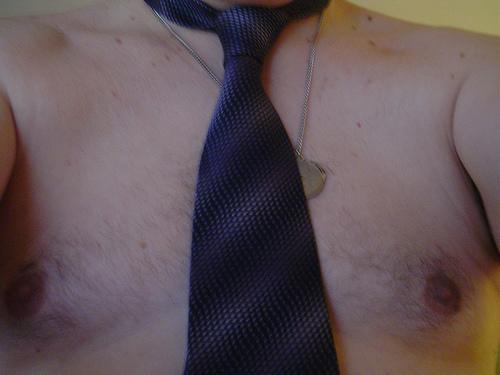What is the name of the clothing?
Quick response, please. Tie. What are the red circles?
Concise answer only. Nipples. Is this person wearing a necklace?
Concise answer only. Yes. Are these clothes appropriate for work?
Quick response, please. No. Is this man sleeping?
Concise answer only. No. Is the human looking figure overweight?
Concise answer only. Yes. 